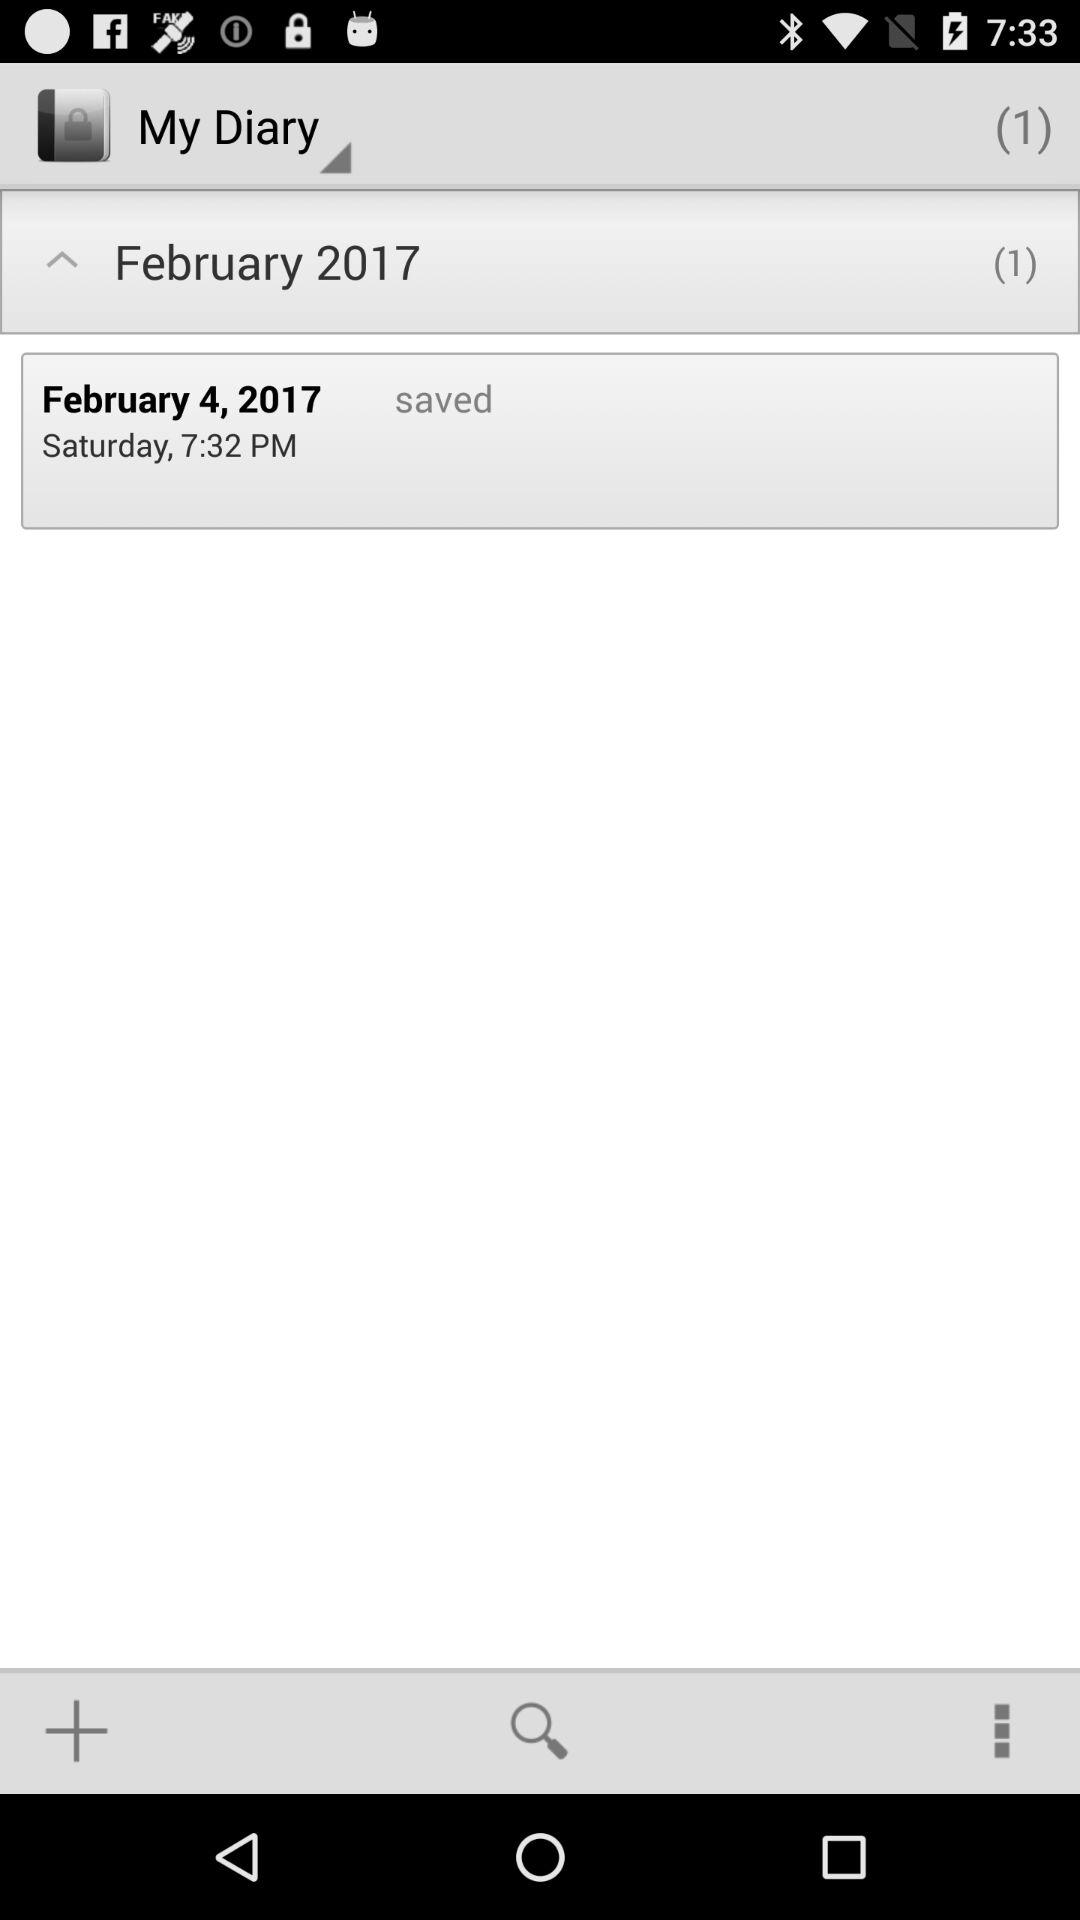What is the total number of notes saved in the "My Diary" section of the application? The total number of notes is 1. 